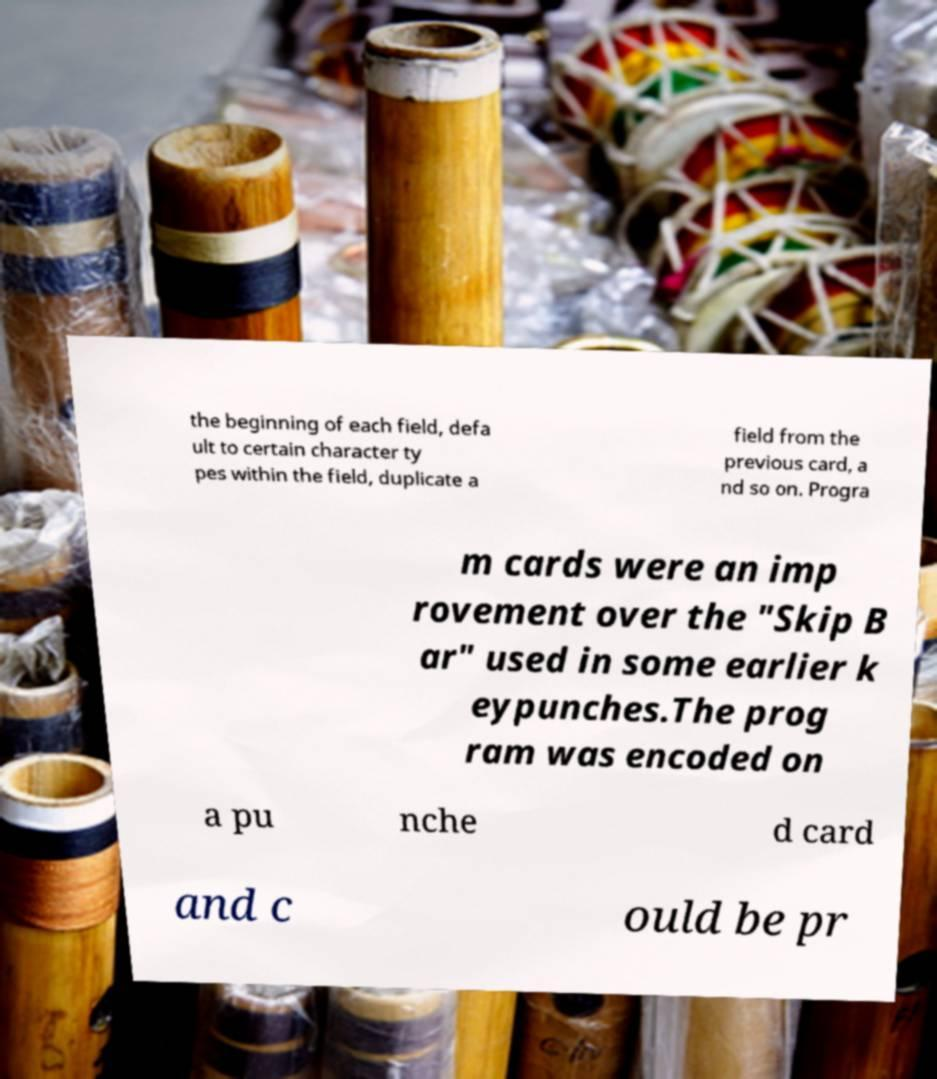There's text embedded in this image that I need extracted. Can you transcribe it verbatim? the beginning of each field, defa ult to certain character ty pes within the field, duplicate a field from the previous card, a nd so on. Progra m cards were an imp rovement over the "Skip B ar" used in some earlier k eypunches.The prog ram was encoded on a pu nche d card and c ould be pr 